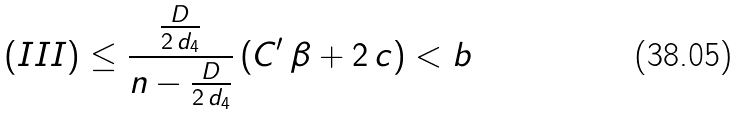Convert formula to latex. <formula><loc_0><loc_0><loc_500><loc_500>( I I I ) \leq \frac { \frac { D } { 2 \, d _ { 4 } } } { n - \frac { D } { 2 \, d _ { 4 } } } \, ( C ^ { \prime } \, \beta + 2 \, c ) < b</formula> 